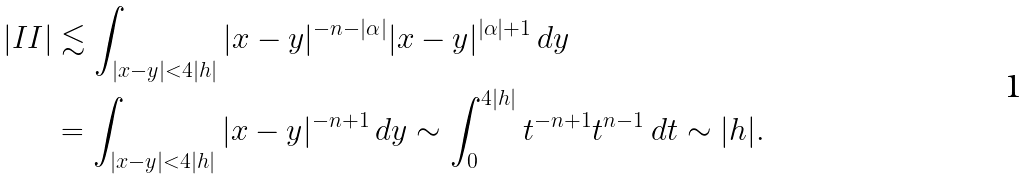Convert formula to latex. <formula><loc_0><loc_0><loc_500><loc_500>| I I | & \lesssim \int _ { | x - y | < 4 | h | } | x - y | ^ { - n - | \alpha | } | x - y | ^ { | \alpha | + 1 } \, d y \\ & = \int _ { | x - y | < 4 | h | } | x - y | ^ { - n + 1 } \, d y \sim \int _ { 0 } ^ { 4 | h | } t ^ { - n + 1 } t ^ { n - 1 } \, d t \sim | h | .</formula> 